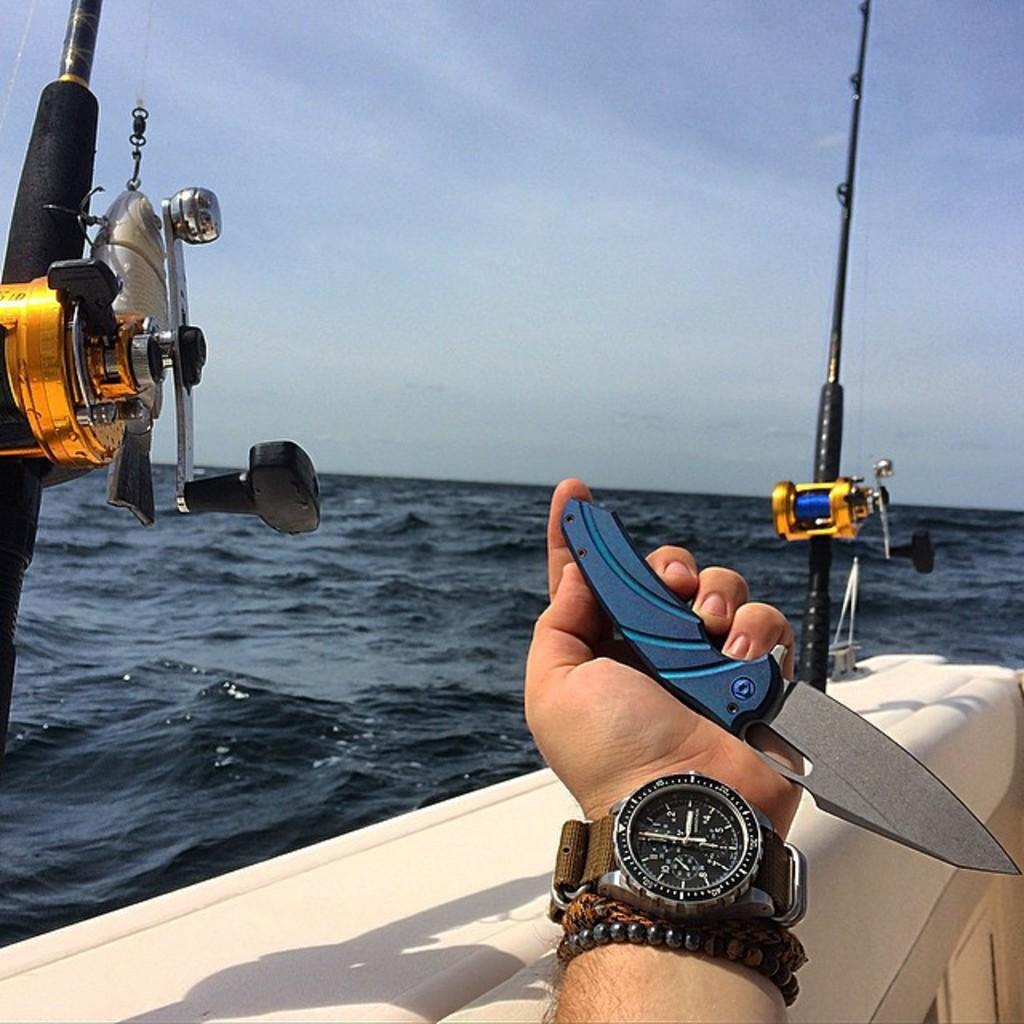<image>
Present a compact description of the photo's key features. A man in a boat who is wearing a watch that says it is 3:00 is also holding a knife. 